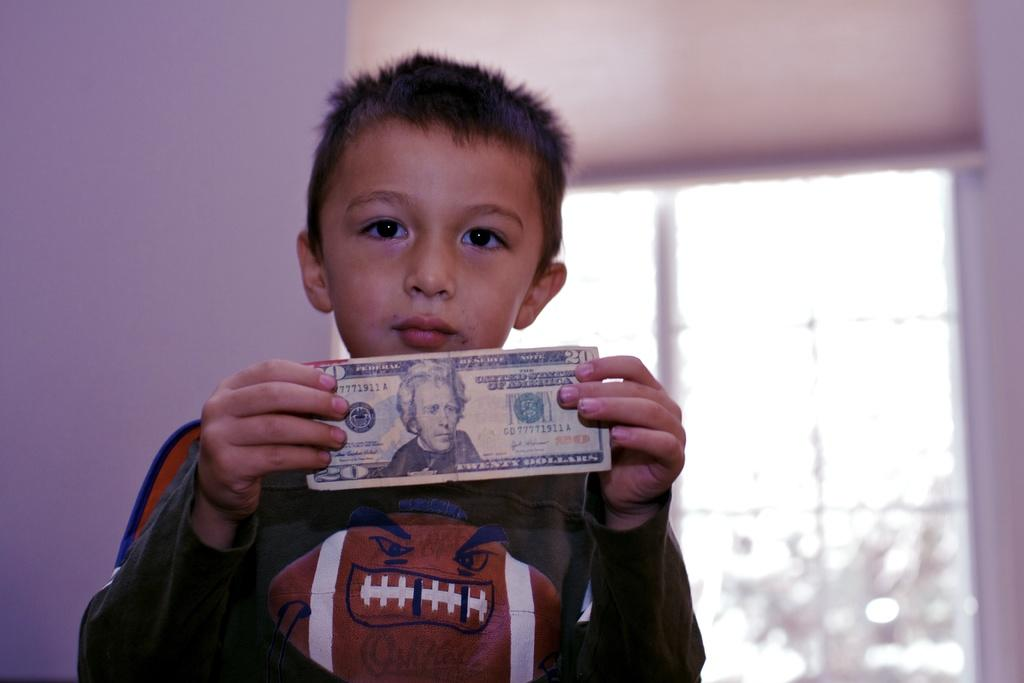<image>
Share a concise interpretation of the image provided. A young male wears a football shirt while holding a twenty dollar bill up. 